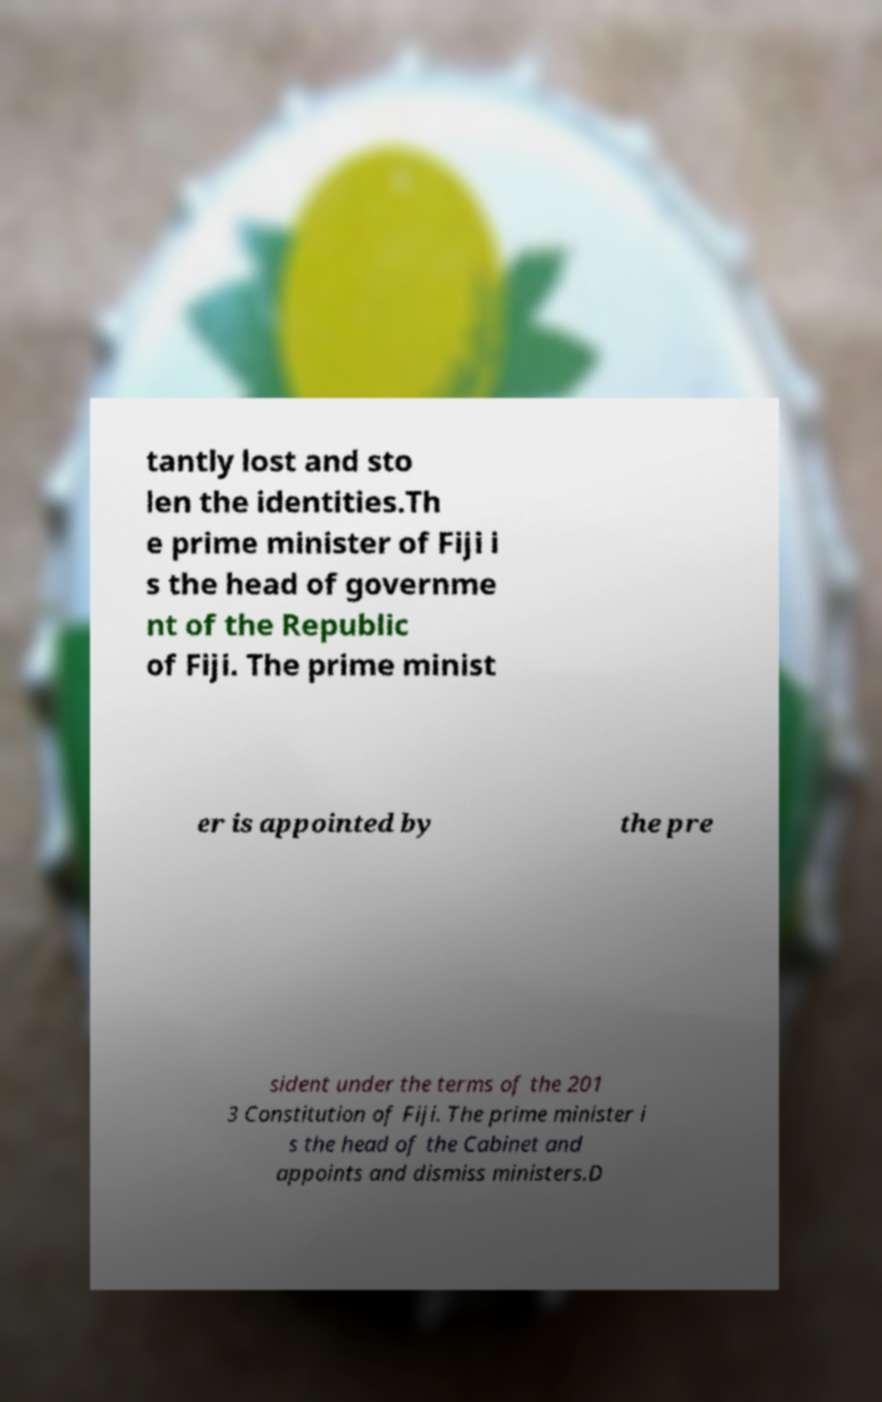Please read and relay the text visible in this image. What does it say? tantly lost and sto len the identities.Th e prime minister of Fiji i s the head of governme nt of the Republic of Fiji. The prime minist er is appointed by the pre sident under the terms of the 201 3 Constitution of Fiji. The prime minister i s the head of the Cabinet and appoints and dismiss ministers.D 